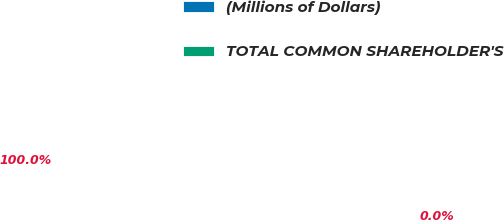Convert chart. <chart><loc_0><loc_0><loc_500><loc_500><pie_chart><fcel>(Millions of Dollars)<fcel>TOTAL COMMON SHAREHOLDER'S<nl><fcel>0.0%<fcel>100.0%<nl></chart> 